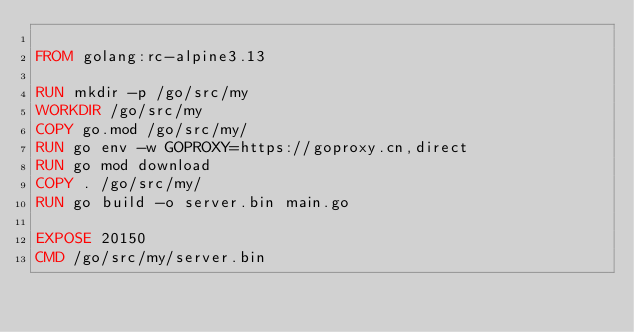<code> <loc_0><loc_0><loc_500><loc_500><_Dockerfile_>
FROM golang:rc-alpine3.13

RUN mkdir -p /go/src/my
WORKDIR /go/src/my
COPY go.mod /go/src/my/
RUN go env -w GOPROXY=https://goproxy.cn,direct
RUN go mod download
COPY . /go/src/my/
RUN go build -o server.bin main.go

EXPOSE 20150
CMD /go/src/my/server.bin</code> 